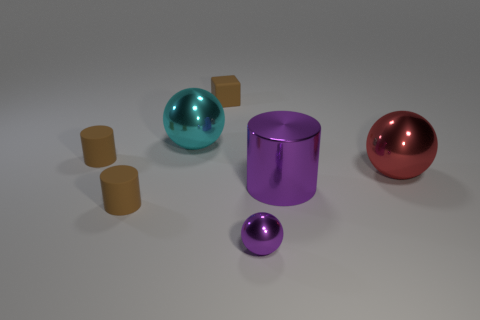Is the tiny purple thing the same shape as the red metal object?
Provide a short and direct response. Yes. Is there any other thing that is the same material as the cyan object?
Provide a succinct answer. Yes. What number of small things are behind the purple metallic cylinder and to the right of the cyan thing?
Offer a terse response. 1. What color is the big ball that is on the right side of the ball on the left side of the small purple ball?
Ensure brevity in your answer.  Red. Are there the same number of tiny purple shiny balls left of the cube and tiny rubber objects?
Provide a succinct answer. No. There is a small rubber thing behind the large ball that is left of the purple cylinder; what number of red metal things are behind it?
Keep it short and to the point. 0. What is the color of the large metal ball that is left of the large red shiny sphere?
Provide a succinct answer. Cyan. There is a cylinder that is left of the cyan sphere and in front of the red sphere; what is its material?
Your answer should be compact. Rubber. There is a cylinder that is behind the purple metal cylinder; what number of big shiny spheres are to the left of it?
Your answer should be compact. 0. What is the shape of the large purple thing?
Your answer should be very brief. Cylinder. 